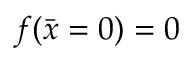<formula> <loc_0><loc_0><loc_500><loc_500>f ( \bar { x } = 0 ) = 0</formula> 